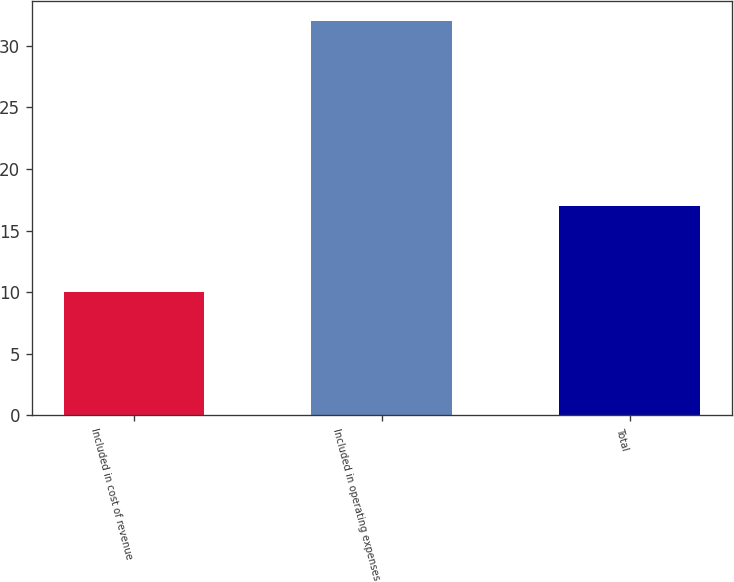<chart> <loc_0><loc_0><loc_500><loc_500><bar_chart><fcel>Included in cost of revenue<fcel>Included in operating expenses<fcel>Total<nl><fcel>10<fcel>32<fcel>17<nl></chart> 